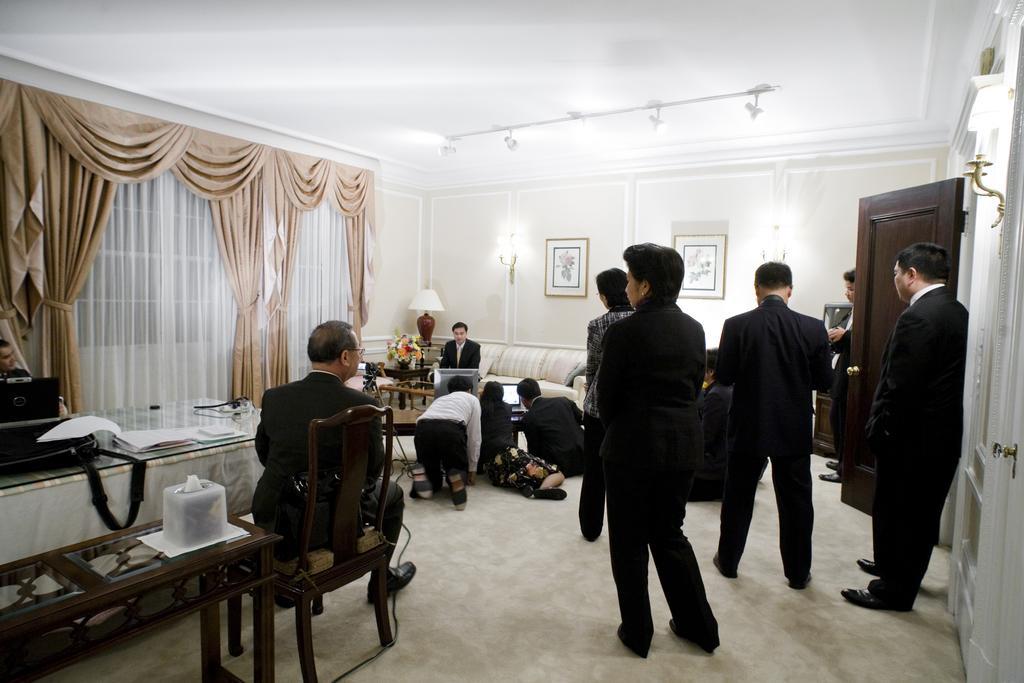How would you summarize this image in a sentence or two? This image is clicked in a room. There are curtains on the left side. There is a table in the left side bottom corner. There are people standing,there are photo frames on the wall. There is one man sitting on the Sofa in the middle, beside him there is a man and on the table on the left side there there are papers, books. There is a door on the right side. 